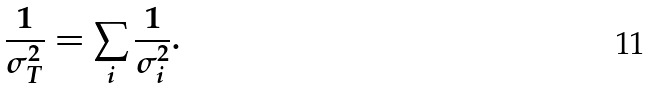Convert formula to latex. <formula><loc_0><loc_0><loc_500><loc_500>\frac { 1 } { \sigma ^ { 2 } _ { T } } = \sum _ { i } \frac { 1 } { \sigma ^ { 2 } _ { i } } .</formula> 